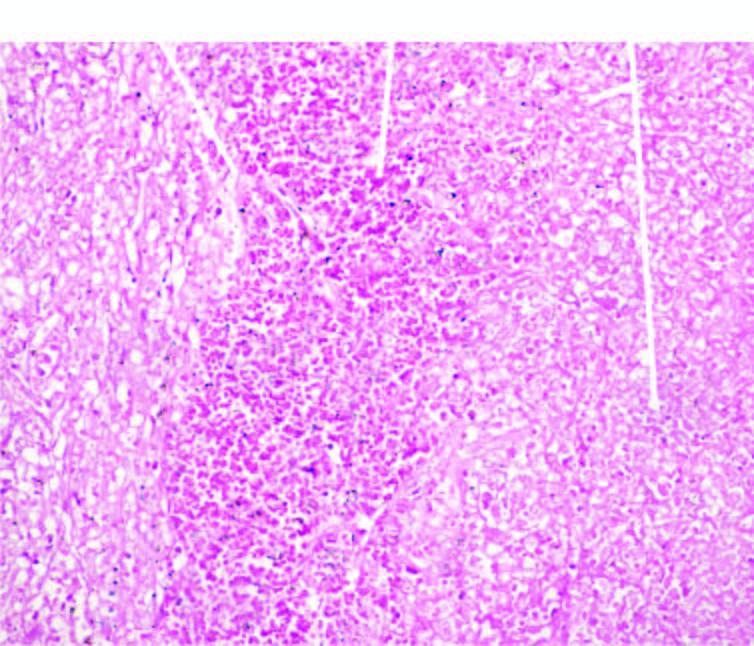does the margin of infracted area show haemorrhage?
Answer the question using a single word or phrase. Yes 